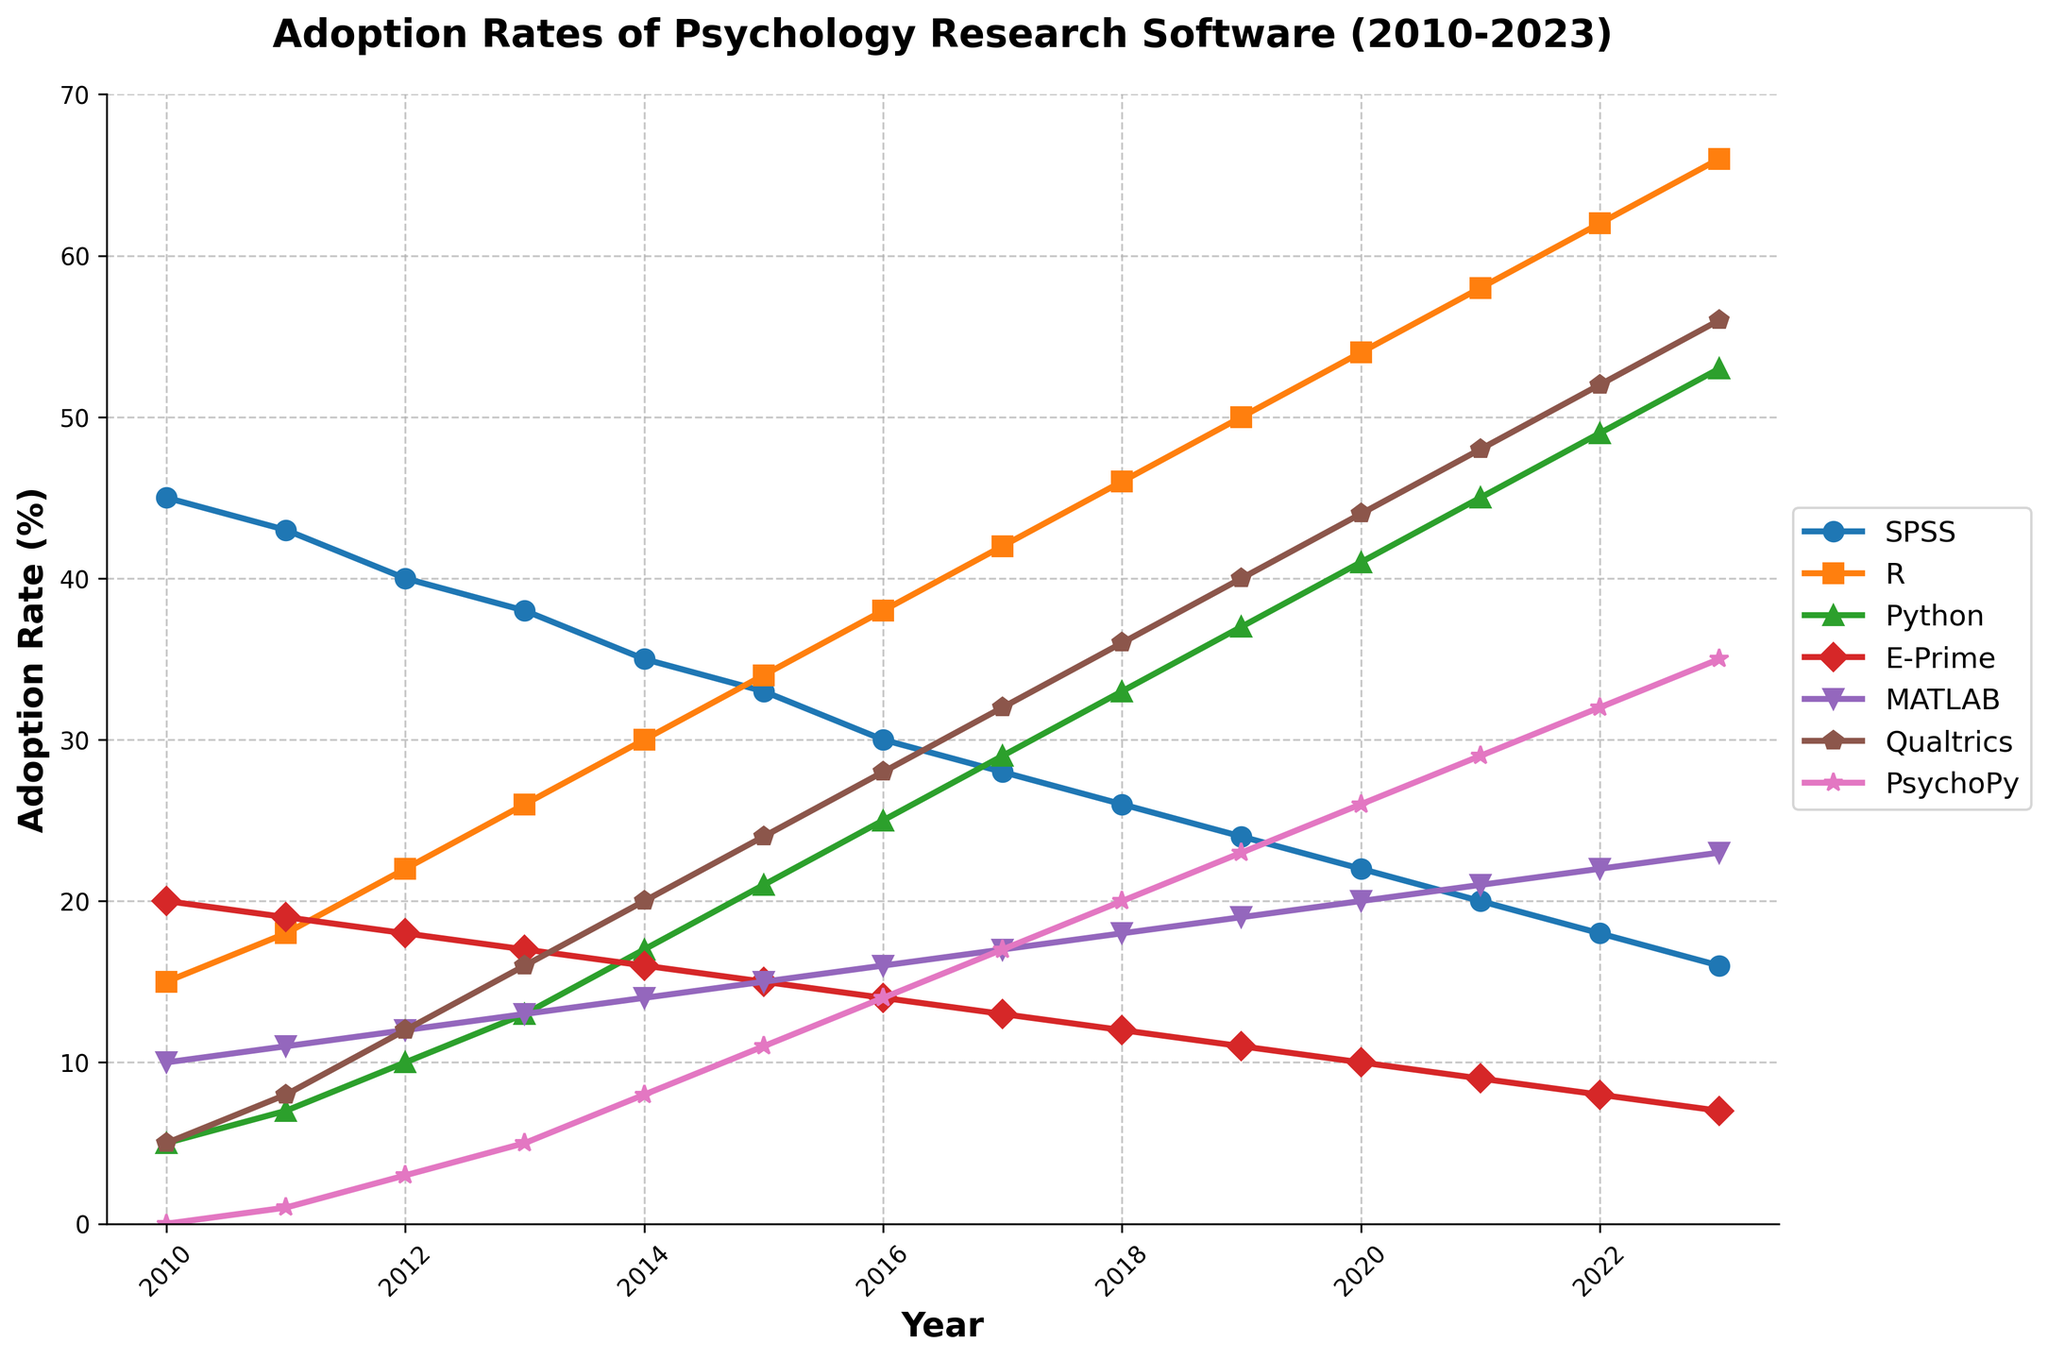What's the adoption rate of Python in 2023? Look at the data point for Python in the year 2023. According to the chart, the adoption rate of Python in 2023 is indicated next to the "Python" line.
Answer: 53% Which software had the highest adoption rate in 2020? To find the answer, compare the adoption rates of all software platforms in the year 2020. The chart shows that R had the highest adoption rate at that time.
Answer: R By how much did the adoption rate of SPSS fall from 2010 to 2023? Calculate the difference in the adoption rate of SPSS between 2010 and 2023 by subtracting the 2023 value from the 2010 value. SPSS adoption rate was 45% in 2010 and 16% in 2023. The difference is 45% - 16% = 29%.
Answer: 29% Which software showed a consistent increase in adoption rate from 2010 to 2023? Identify which lines consistently trend upwards from 2010 to 2023. According to the chart, R, Python, and Qualtrics showed a consistent increase in their adoption rates over this period.
Answer: R, Python, Qualtrics Did any software have a higher adoption rate than MATLAB in 2015? Compare the adoption rates of other software platforms with MATLAB in 2015. MATLAB had a rate of 15%. SPSS (33%), R (34%), and Python (21%) had higher adoption rates than MATLAB in that year.
Answer: SPSS, R, Python In which year did PsychoPy appear on the chart? Find the first year where PsychoPy is recorded with a non-zero value. According to the data, PsychoPy appears in 2011 with an adoption rate of 1%.
Answer: 2011 What is the average adoption rate of Qualtrics from 2010 to 2023? Sum up all the yearly adoption rates for Qualtrics, then divide by the number of years (2023 - 2010 + 1). The total for Qualtrics is 5+8+12+16+20+24+28+32+36+40+44+48+52+56 = 421. Divide this by 14 years: 421/14 ≈ 30.07%.
Answer: 30.07% Which two software platforms had the closest adoption rates in 2013? Compare the values for all platforms in 2013 and identify the smallest difference. Python and MATLAB had adoption rates of 13% and 13% respectively.
Answer: Python, MATLAB In 2023, which software had the second-lowest adoption rate? Sort the software adoption rates in 2023 from lowest to highest. The second-lowest rate is for E-Prime with 7%.
Answer: E-Prime What is the visual color used for representing SPSS in the chart? Identify the color associated with the SPSS line on the chart. It's represented by the default blue color, often the first color in the palette.
Answer: blue 